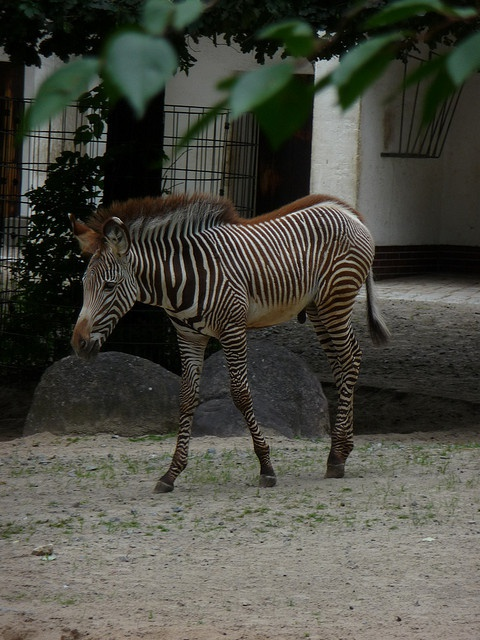Describe the objects in this image and their specific colors. I can see a zebra in black, gray, and maroon tones in this image. 